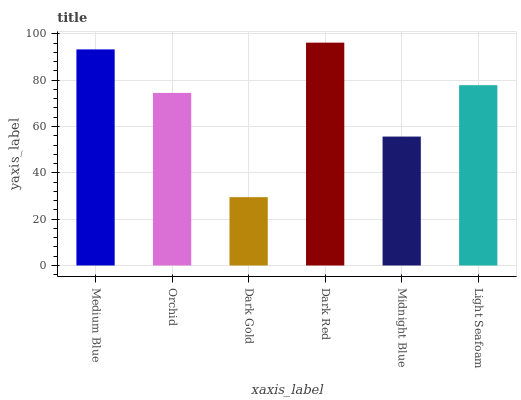Is Dark Gold the minimum?
Answer yes or no. Yes. Is Dark Red the maximum?
Answer yes or no. Yes. Is Orchid the minimum?
Answer yes or no. No. Is Orchid the maximum?
Answer yes or no. No. Is Medium Blue greater than Orchid?
Answer yes or no. Yes. Is Orchid less than Medium Blue?
Answer yes or no. Yes. Is Orchid greater than Medium Blue?
Answer yes or no. No. Is Medium Blue less than Orchid?
Answer yes or no. No. Is Light Seafoam the high median?
Answer yes or no. Yes. Is Orchid the low median?
Answer yes or no. Yes. Is Dark Gold the high median?
Answer yes or no. No. Is Midnight Blue the low median?
Answer yes or no. No. 